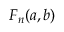Convert formula to latex. <formula><loc_0><loc_0><loc_500><loc_500>F _ { n } ( a , b )</formula> 